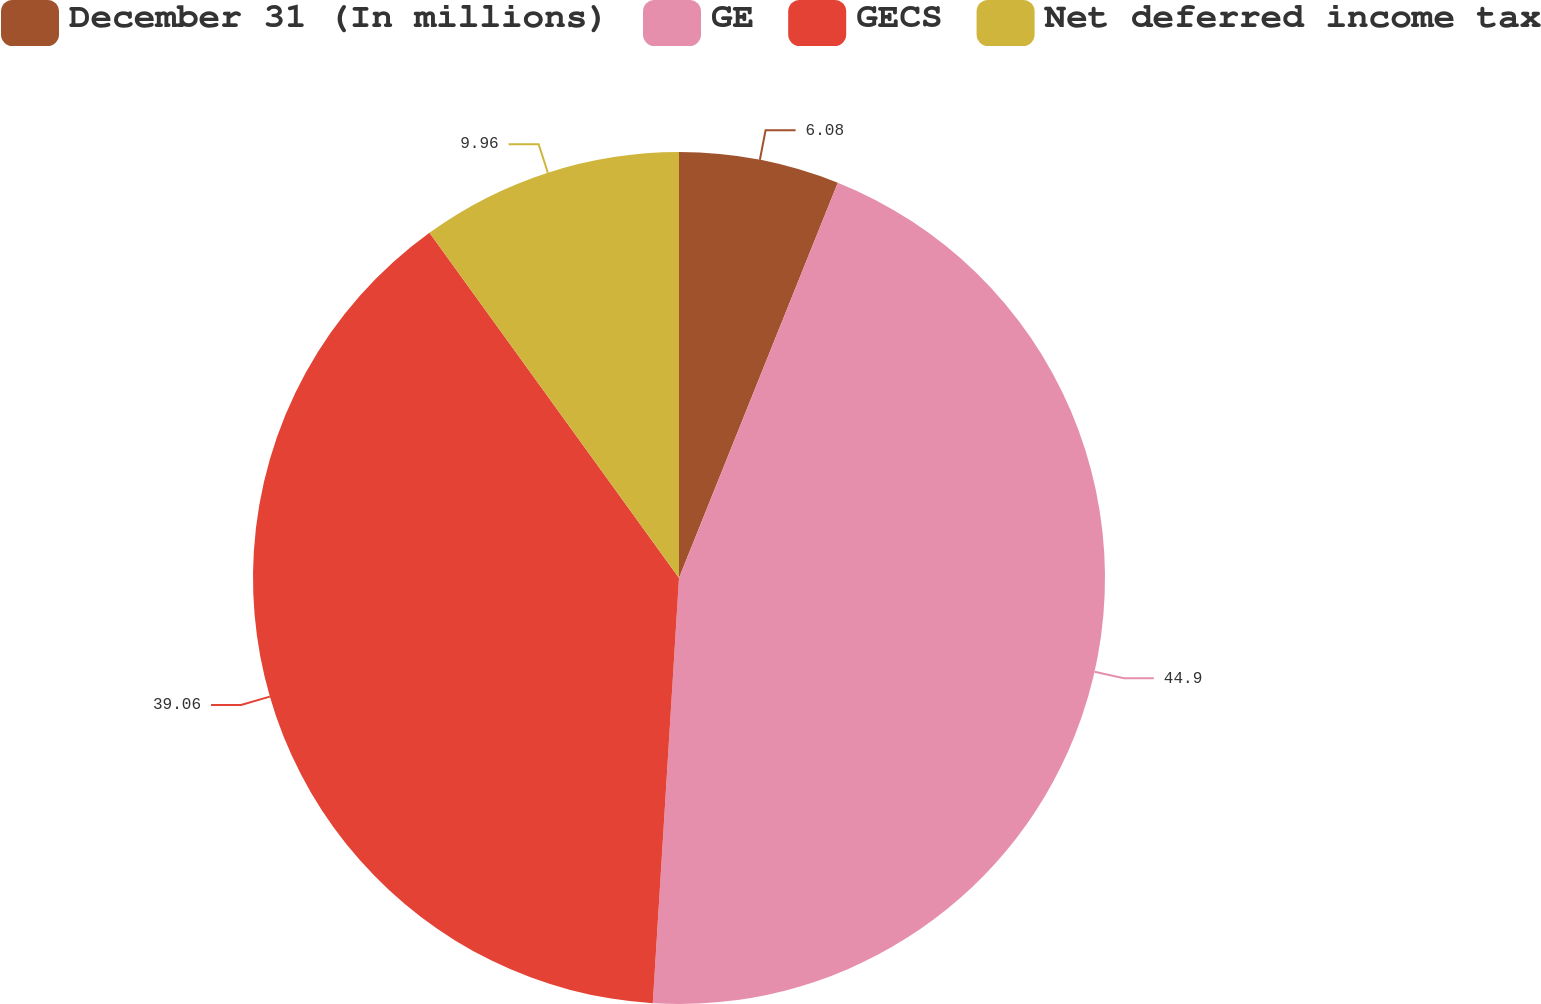Convert chart. <chart><loc_0><loc_0><loc_500><loc_500><pie_chart><fcel>December 31 (In millions)<fcel>GE<fcel>GECS<fcel>Net deferred income tax<nl><fcel>6.08%<fcel>44.9%<fcel>39.06%<fcel>9.96%<nl></chart> 